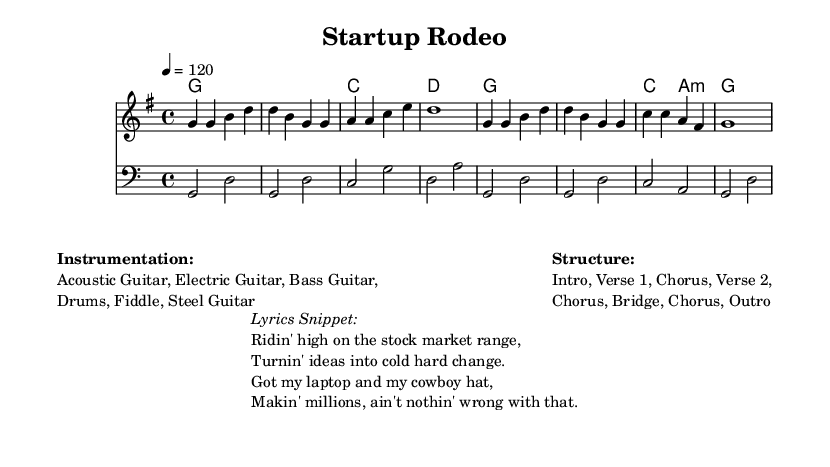What is the key signature of this music? The key signature is G major, which has one sharp (F#).
Answer: G major What is the time signature of this music? The time signature is 4/4, which means there are four beats in a measure and a quarter note gets one beat.
Answer: 4/4 What is the tempo of this music? The tempo is set at 120 beats per minute, indicating how fast the piece should be played.
Answer: 120 How many instruments are used in this piece? The notation indicates the presence of five instruments: Acoustic Guitar, Electric Guitar, Bass Guitar, Drums, Fiddle, and Steel Guitar.
Answer: Six What is the structure of this song? The structure consists of an Intro, Verse 1, Chorus, Verse 2, Chorus, Bridge, Chorus, and Outro.
Answer: Intro, Verse 1, Chorus, Verse 2, Chorus, Bridge, Chorus, Outro Which lyrical theme is emphasized in the lyrics snippet? The lyrics focus on financial success and entrepreneurship, highlighting the transition from ideas to tangible wealth.
Answer: Financial success and entrepreneurship What is the primary mood conveyed in this country song? The song expresses a positive and entrepreneurial spirit, reflecting ambition and success in the business realm.
Answer: Positive and entrepreneurial spirit 